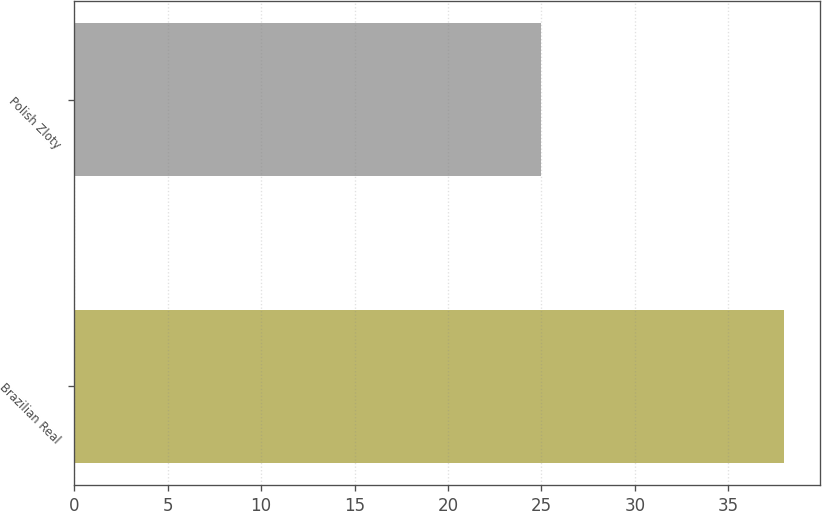Convert chart to OTSL. <chart><loc_0><loc_0><loc_500><loc_500><bar_chart><fcel>Brazilian Real<fcel>Polish Zloty<nl><fcel>38<fcel>25<nl></chart> 